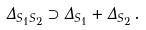<formula> <loc_0><loc_0><loc_500><loc_500>\Delta _ { S _ { 1 } S _ { 2 } } \supset \Delta _ { S _ { 1 } } + \Delta _ { S _ { 2 } } \, .</formula> 